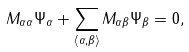Convert formula to latex. <formula><loc_0><loc_0><loc_500><loc_500>M _ { \alpha \alpha } \Psi _ { \alpha } + \sum _ { \langle \alpha , \beta \rangle } M _ { \alpha \beta } \Psi _ { \beta } = 0 ,</formula> 